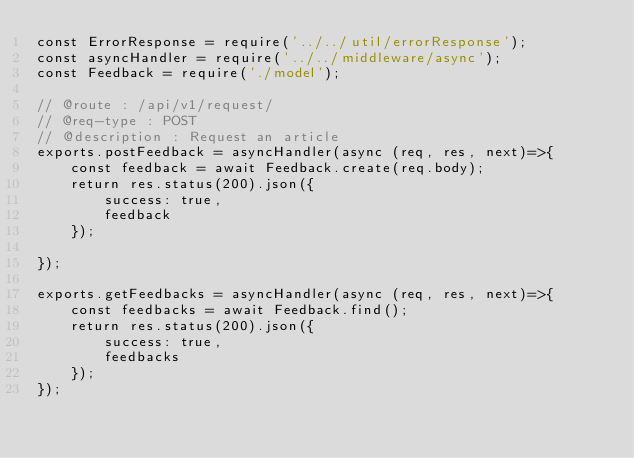Convert code to text. <code><loc_0><loc_0><loc_500><loc_500><_JavaScript_>const ErrorResponse = require('../../util/errorResponse');
const asyncHandler = require('../../middleware/async');
const Feedback = require('./model');

// @route : /api/v1/request/
// @req-type : POST
// @description : Request an article
exports.postFeedback = asyncHandler(async (req, res, next)=>{
    const feedback = await Feedback.create(req.body);
    return res.status(200).json({
        success: true,
        feedback
    });

});

exports.getFeedbacks = asyncHandler(async (req, res, next)=>{
    const feedbacks = await Feedback.find();
    return res.status(200).json({
        success: true,
        feedbacks
    });
});</code> 